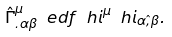<formula> <loc_0><loc_0><loc_500><loc_500>\hat { \Gamma } ^ { \mu } _ { . \alpha \beta } \ e d f { \ h { i } } ^ { \mu } \ h { i } _ { \alpha \hat { , } \beta } .</formula> 